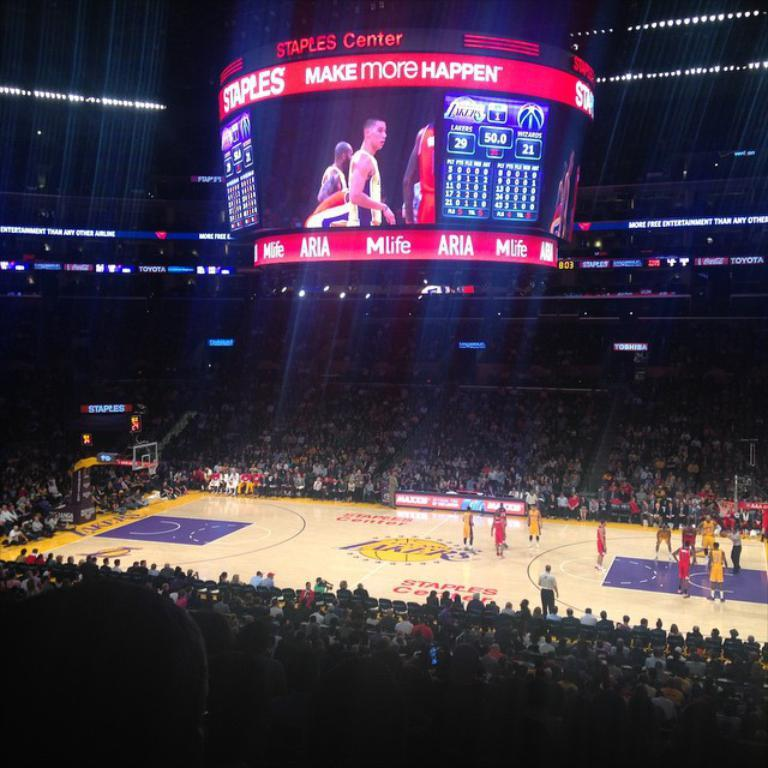Provide a one-sentence caption for the provided image. a court for basketball and a scoreboard with Make more happen on it. 